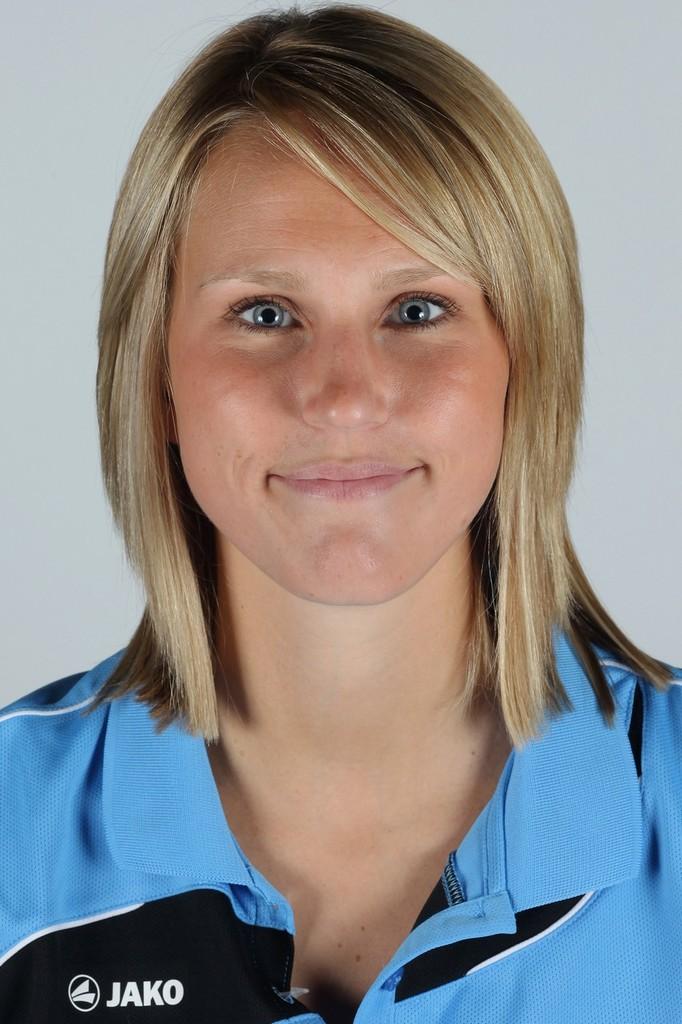What brand of clothing is it?
Make the answer very short. Jako. 